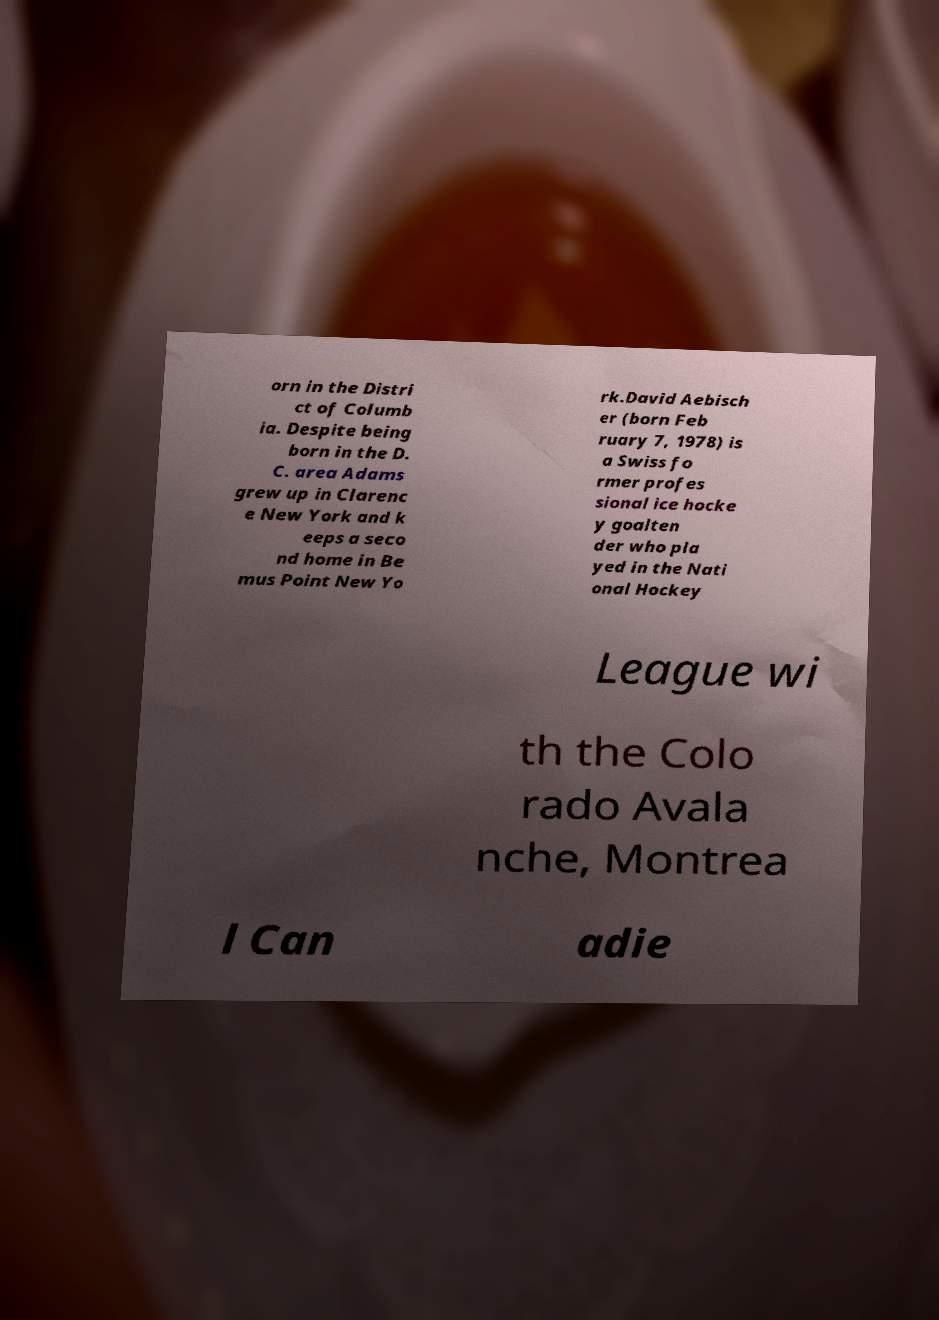Could you extract and type out the text from this image? orn in the Distri ct of Columb ia. Despite being born in the D. C. area Adams grew up in Clarenc e New York and k eeps a seco nd home in Be mus Point New Yo rk.David Aebisch er (born Feb ruary 7, 1978) is a Swiss fo rmer profes sional ice hocke y goalten der who pla yed in the Nati onal Hockey League wi th the Colo rado Avala nche, Montrea l Can adie 